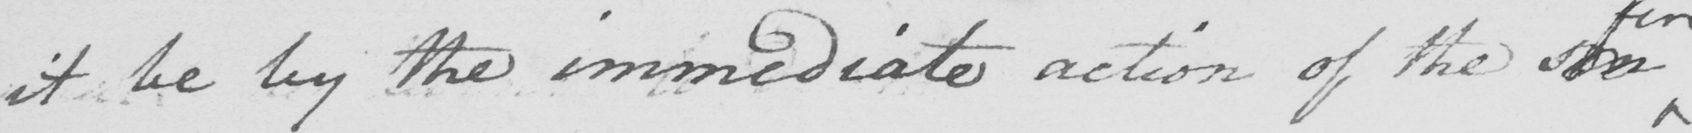Please transcribe the handwritten text in this image. it be by the immediate notion of the  <gap/> 